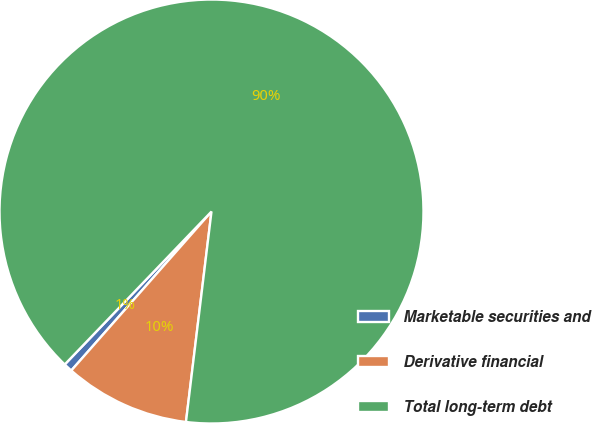Convert chart. <chart><loc_0><loc_0><loc_500><loc_500><pie_chart><fcel>Marketable securities and<fcel>Derivative financial<fcel>Total long-term debt<nl><fcel>0.67%<fcel>9.58%<fcel>89.75%<nl></chart> 